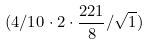<formula> <loc_0><loc_0><loc_500><loc_500>( 4 / 1 0 \cdot 2 \cdot \frac { 2 2 1 } { 8 } / \sqrt { 1 } )</formula> 